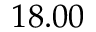Convert formula to latex. <formula><loc_0><loc_0><loc_500><loc_500>1 8 . 0 0</formula> 